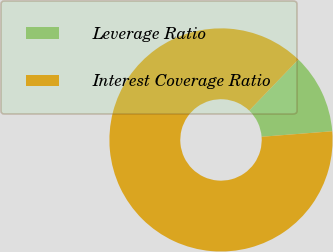<chart> <loc_0><loc_0><loc_500><loc_500><pie_chart><fcel>Leverage Ratio<fcel>Interest Coverage Ratio<nl><fcel>11.57%<fcel>88.43%<nl></chart> 